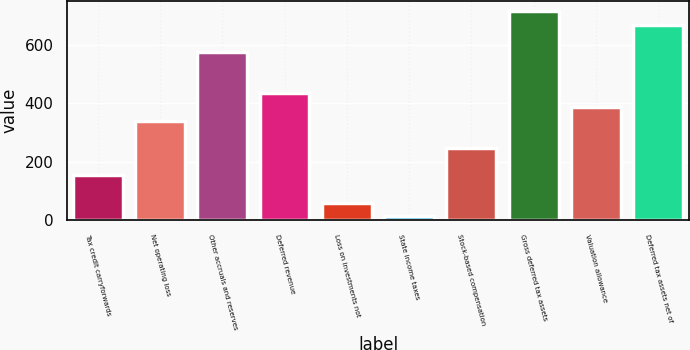Convert chart. <chart><loc_0><loc_0><loc_500><loc_500><bar_chart><fcel>Tax credit carryforwards<fcel>Net operating loss<fcel>Other accruals and reserves<fcel>Deferred revenue<fcel>Loss on investments not<fcel>State income taxes<fcel>Stock-based compensation<fcel>Gross deferred tax assets<fcel>Valuation allowance<fcel>Deferred tax assets net of<nl><fcel>154.1<fcel>340.9<fcel>574.4<fcel>434.3<fcel>60.7<fcel>14<fcel>247.5<fcel>714.5<fcel>387.6<fcel>667.8<nl></chart> 